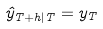Convert formula to latex. <formula><loc_0><loc_0><loc_500><loc_500>\hat { y } _ { T + h | T } = y _ { T }</formula> 